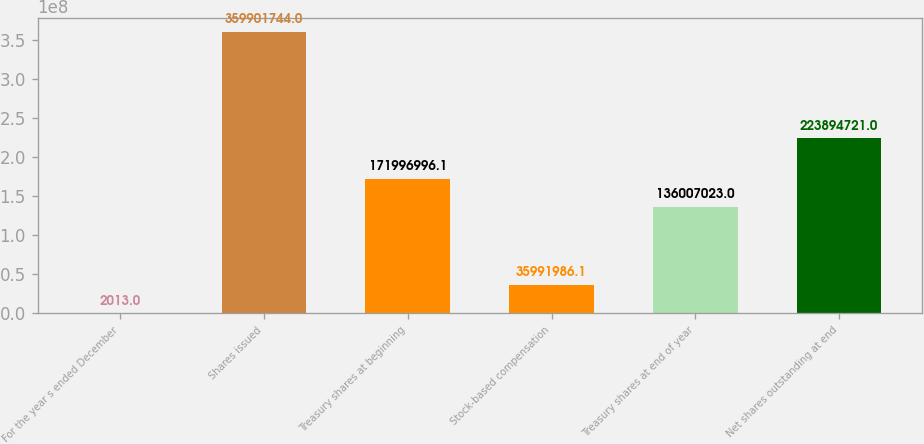<chart> <loc_0><loc_0><loc_500><loc_500><bar_chart><fcel>For the year s ended December<fcel>Shares issued<fcel>Treasury shares at beginning<fcel>Stock-based compensation<fcel>Treasury shares at end of year<fcel>Net shares outstanding at end<nl><fcel>2013<fcel>3.59902e+08<fcel>1.71997e+08<fcel>3.5992e+07<fcel>1.36007e+08<fcel>2.23895e+08<nl></chart> 